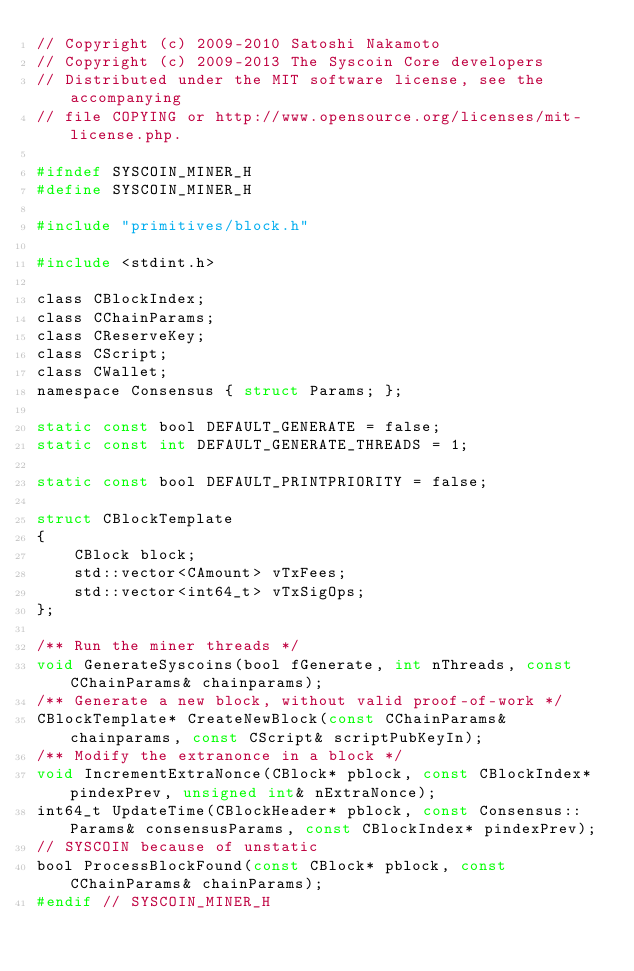<code> <loc_0><loc_0><loc_500><loc_500><_C_>// Copyright (c) 2009-2010 Satoshi Nakamoto
// Copyright (c) 2009-2013 The Syscoin Core developers
// Distributed under the MIT software license, see the accompanying
// file COPYING or http://www.opensource.org/licenses/mit-license.php.

#ifndef SYSCOIN_MINER_H
#define SYSCOIN_MINER_H

#include "primitives/block.h"

#include <stdint.h>

class CBlockIndex;
class CChainParams;
class CReserveKey;
class CScript;
class CWallet;
namespace Consensus { struct Params; };

static const bool DEFAULT_GENERATE = false;
static const int DEFAULT_GENERATE_THREADS = 1;

static const bool DEFAULT_PRINTPRIORITY = false;

struct CBlockTemplate
{
    CBlock block;
    std::vector<CAmount> vTxFees;
    std::vector<int64_t> vTxSigOps;
};

/** Run the miner threads */
void GenerateSyscoins(bool fGenerate, int nThreads, const CChainParams& chainparams);
/** Generate a new block, without valid proof-of-work */
CBlockTemplate* CreateNewBlock(const CChainParams& chainparams, const CScript& scriptPubKeyIn);
/** Modify the extranonce in a block */
void IncrementExtraNonce(CBlock* pblock, const CBlockIndex* pindexPrev, unsigned int& nExtraNonce);
int64_t UpdateTime(CBlockHeader* pblock, const Consensus::Params& consensusParams, const CBlockIndex* pindexPrev);
// SYSCOIN because of unstatic
bool ProcessBlockFound(const CBlock* pblock, const CChainParams& chainParams);
#endif // SYSCOIN_MINER_H
</code> 